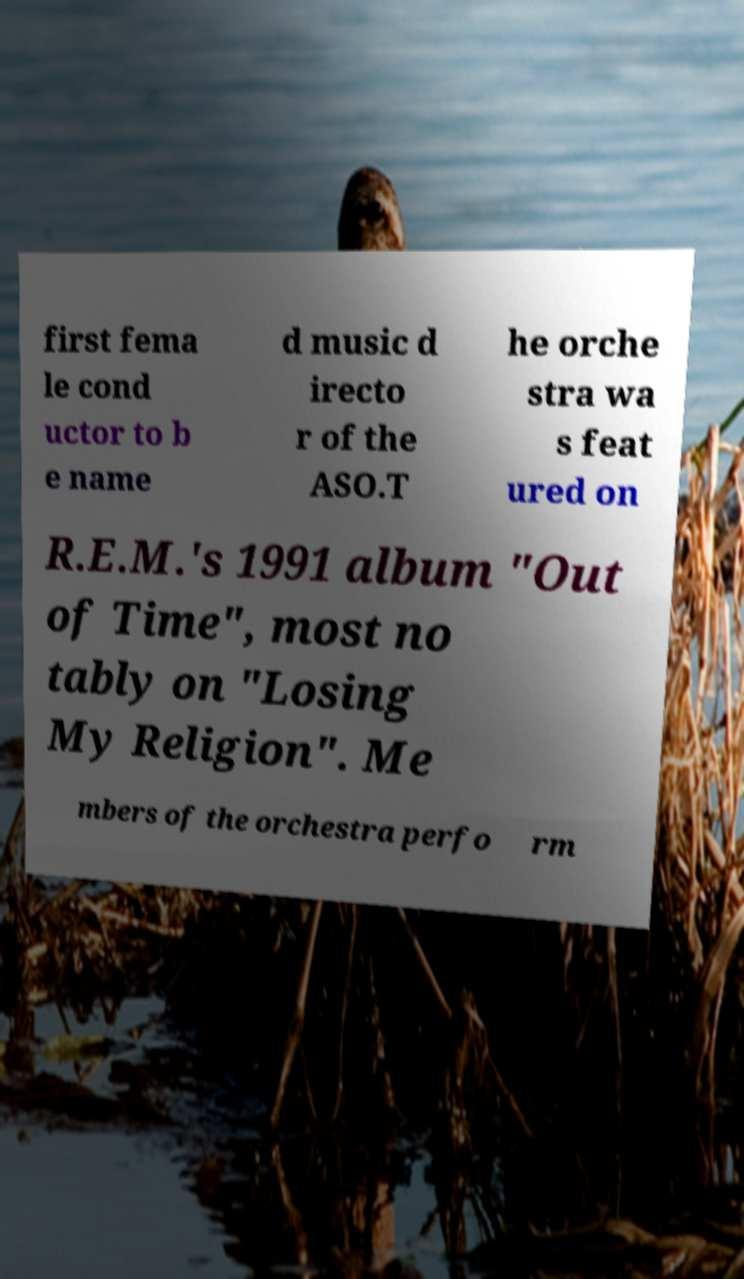I need the written content from this picture converted into text. Can you do that? first fema le cond uctor to b e name d music d irecto r of the ASO.T he orche stra wa s feat ured on R.E.M.'s 1991 album "Out of Time", most no tably on "Losing My Religion". Me mbers of the orchestra perfo rm 